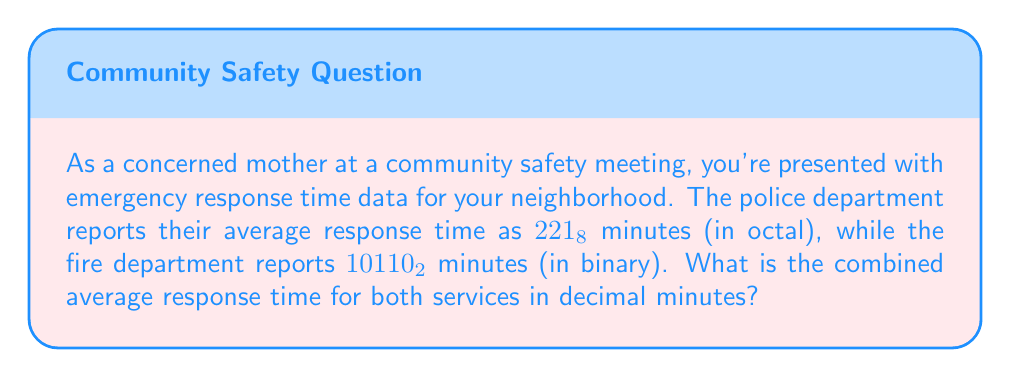Give your solution to this math problem. To solve this problem, we need to follow these steps:

1. Convert the police response time from octal to decimal:
   $221_8 = 2 \times 8^2 + 2 \times 8^1 + 1 \times 8^0 = 128 + 16 + 1 = 145$ decimal minutes

2. Convert the fire department response time from binary to decimal:
   $10110_2 = 1 \times 2^4 + 0 \times 2^3 + 1 \times 2^2 + 1 \times 2^1 + 0 \times 2^0 = 16 + 0 + 4 + 2 + 0 = 22$ decimal minutes

3. Calculate the average of the two response times:
   $$\text{Average} = \frac{\text{Police response time} + \text{Fire department response time}}{2}$$
   $$\text{Average} = \frac{145 + 22}{2} = \frac{167}{2} = 83.5$$

Therefore, the combined average response time for both services is 83.5 minutes in decimal.
Answer: 83.5 minutes 